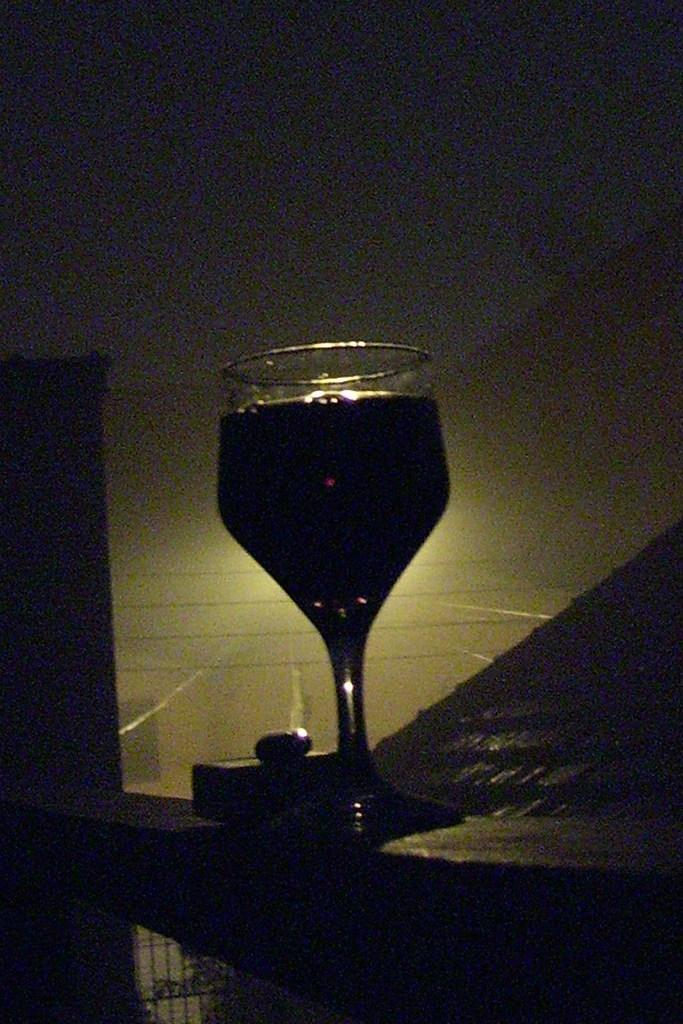What is in the glass that is visible in the image? There is a glass of drink in the image. What is the glass of drink placed on? The glass of drink is placed on an object. What can be seen in the background of the image? There is a wall in the background of the image, and there are other unspecified objects present as well. What role does the grandfather play in the battle depicted in the image? There is no battle or grandfather present in the image. What is the chin of the person holding the glass in the image? There is no person holding the glass in the image, and therefore no chin can be observed. 